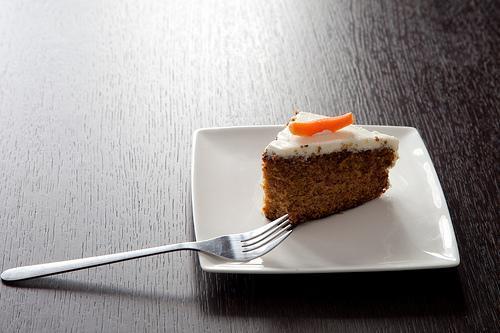How many pieces of cake are there?
Give a very brief answer. 1. 